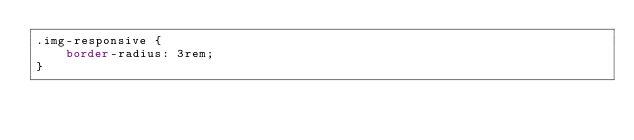Convert code to text. <code><loc_0><loc_0><loc_500><loc_500><_CSS_>.img-responsive {
    border-radius: 3rem;
}</code> 